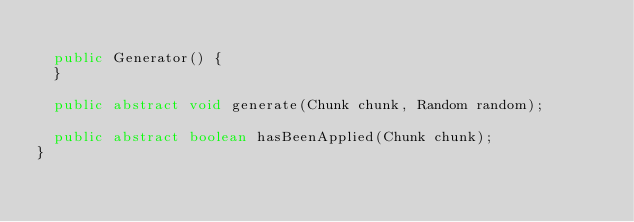Convert code to text. <code><loc_0><loc_0><loc_500><loc_500><_Java_>	
	public Generator() {
	}
	
	public abstract void generate(Chunk chunk, Random random);

	public abstract boolean hasBeenApplied(Chunk chunk);
}</code> 